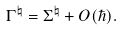Convert formula to latex. <formula><loc_0><loc_0><loc_500><loc_500>\Gamma ^ { \natural } = \Sigma ^ { \natural } + O ( \hbar { ) } .</formula> 